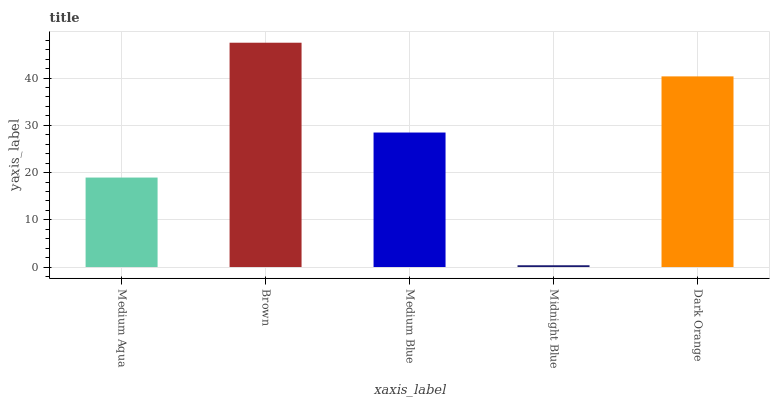Is Midnight Blue the minimum?
Answer yes or no. Yes. Is Brown the maximum?
Answer yes or no. Yes. Is Medium Blue the minimum?
Answer yes or no. No. Is Medium Blue the maximum?
Answer yes or no. No. Is Brown greater than Medium Blue?
Answer yes or no. Yes. Is Medium Blue less than Brown?
Answer yes or no. Yes. Is Medium Blue greater than Brown?
Answer yes or no. No. Is Brown less than Medium Blue?
Answer yes or no. No. Is Medium Blue the high median?
Answer yes or no. Yes. Is Medium Blue the low median?
Answer yes or no. Yes. Is Midnight Blue the high median?
Answer yes or no. No. Is Midnight Blue the low median?
Answer yes or no. No. 